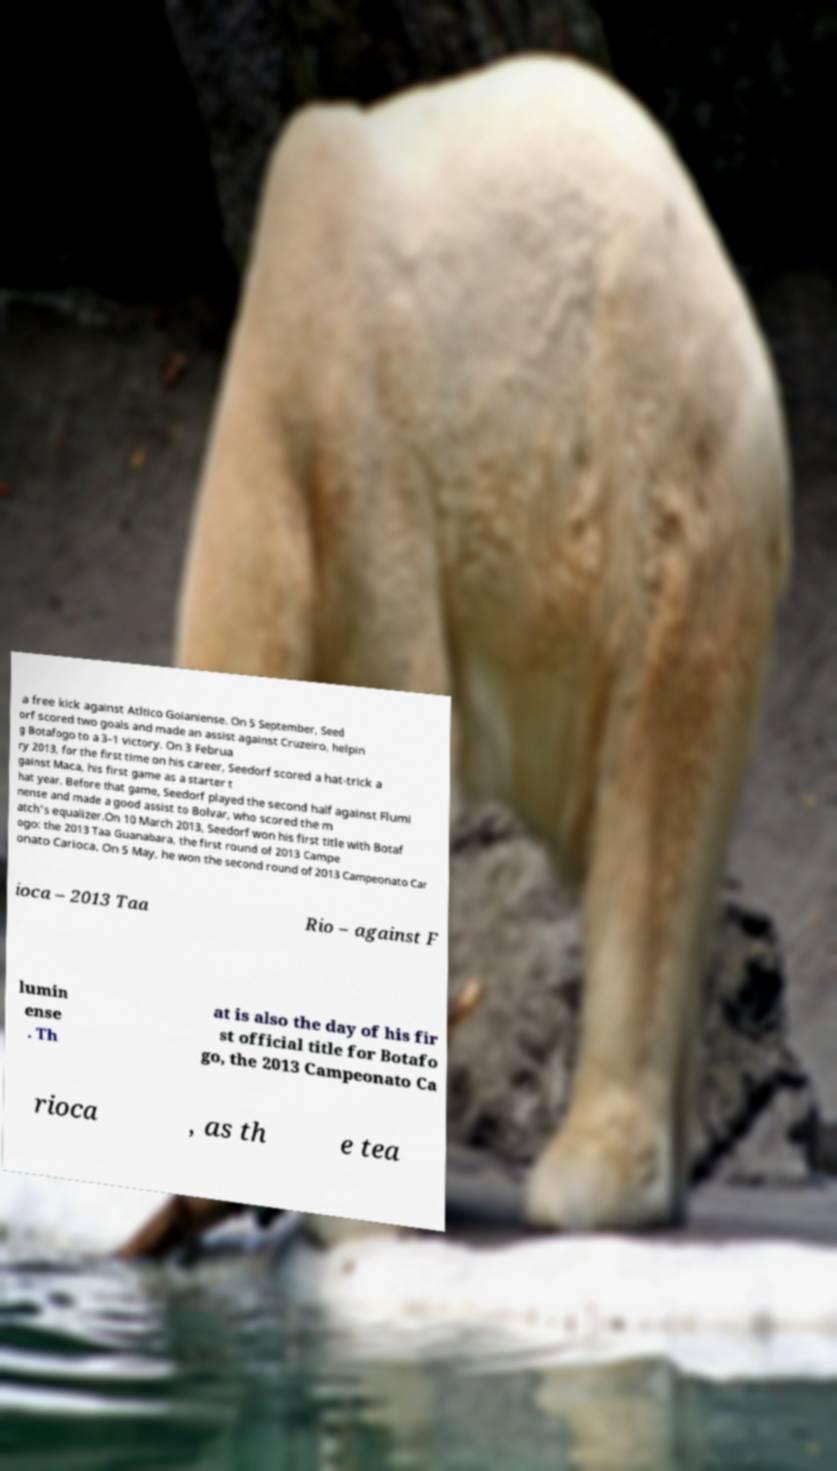I need the written content from this picture converted into text. Can you do that? a free kick against Atltico Goianiense. On 5 September, Seed orf scored two goals and made an assist against Cruzeiro, helpin g Botafogo to a 3–1 victory. On 3 Februa ry 2013, for the first time on his career, Seedorf scored a hat-trick a gainst Maca, his first game as a starter t hat year. Before that game, Seedorf played the second half against Flumi nense and made a good assist to Bolvar, who scored the m atch's equalizer.On 10 March 2013, Seedorf won his first title with Botaf ogo: the 2013 Taa Guanabara, the first round of 2013 Campe onato Carioca. On 5 May, he won the second round of 2013 Campeonato Car ioca – 2013 Taa Rio – against F lumin ense . Th at is also the day of his fir st official title for Botafo go, the 2013 Campeonato Ca rioca , as th e tea 